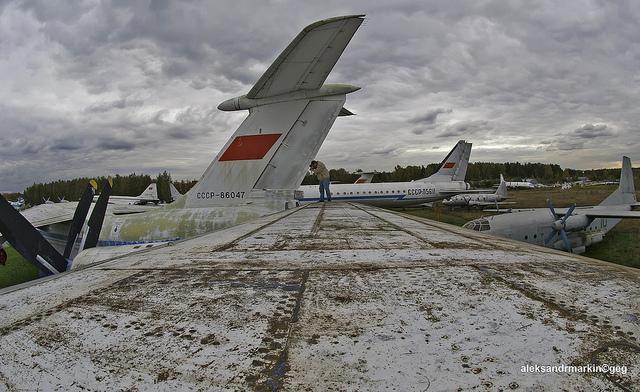How many airplanes are there?
Give a very brief answer. 3. 